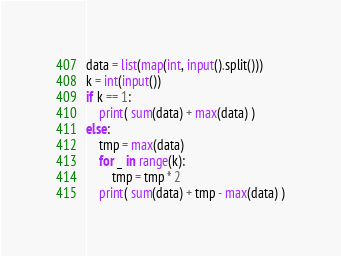<code> <loc_0><loc_0><loc_500><loc_500><_Python_>data = list(map(int, input().split()))
k = int(input())
if k == 1:
    print( sum(data) + max(data) )
else:
    tmp = max(data)
    for _ in range(k):
        tmp = tmp * 2
    print( sum(data) + tmp - max(data) )
</code> 